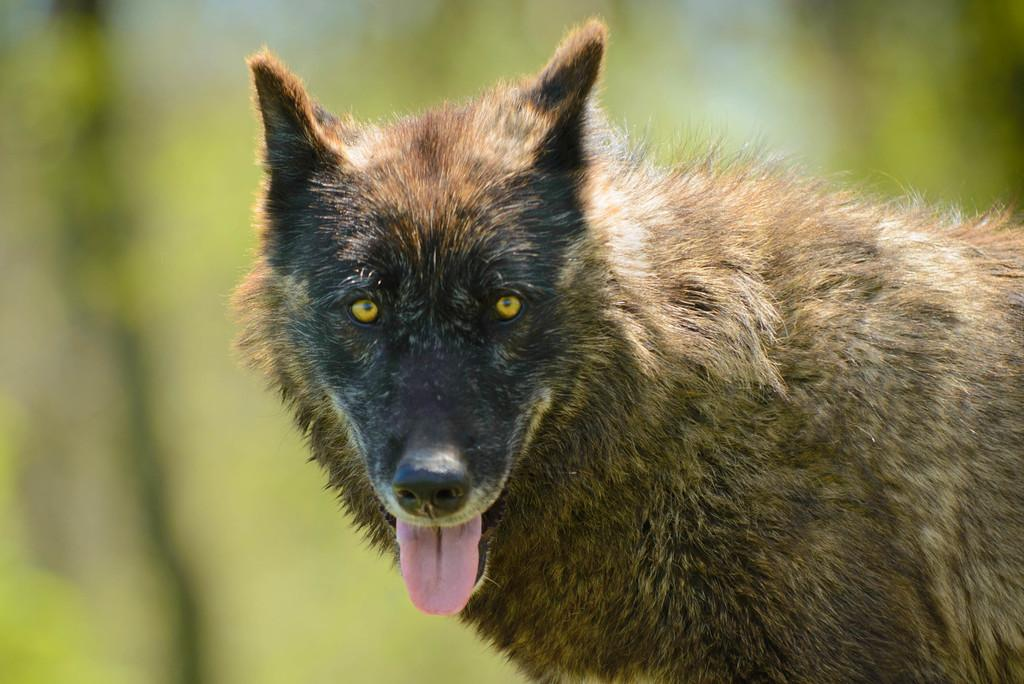What type of animal is in the image? The specific type of animal cannot be determined from the provided facts. Can you describe the background of the image? The background of the image is blurred. What type of jewel is being sold at the market in the image? There is no market or jewel present in the image; it only features an animal and a blurred background. 